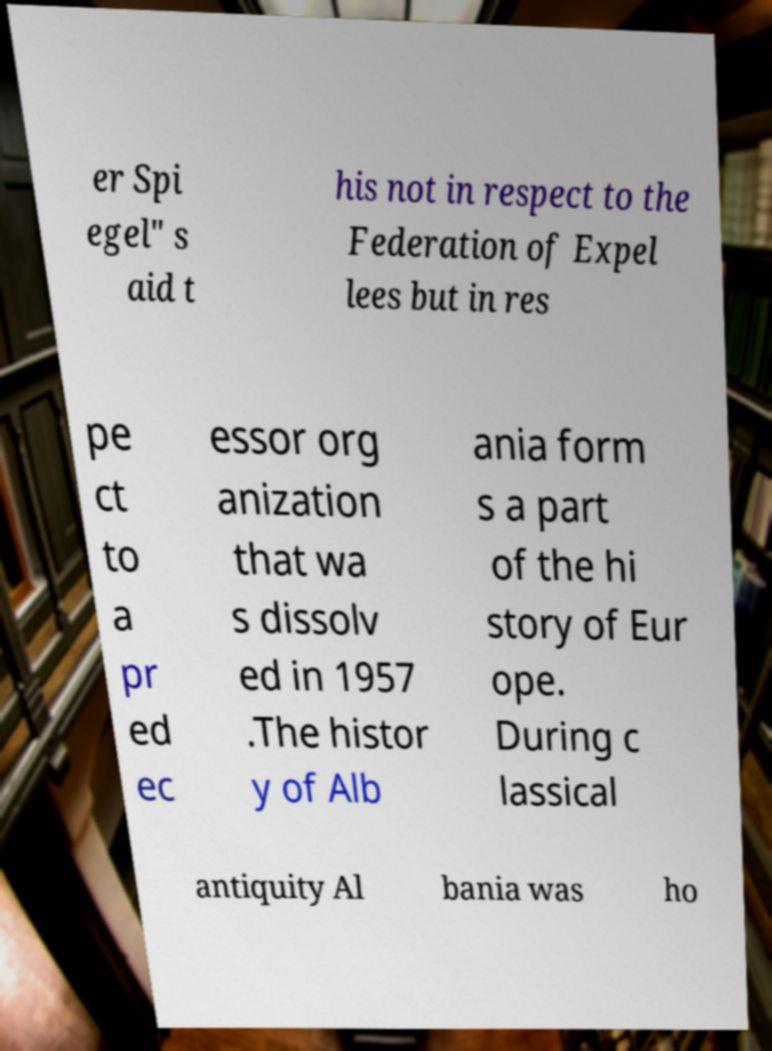Please identify and transcribe the text found in this image. er Spi egel" s aid t his not in respect to the Federation of Expel lees but in res pe ct to a pr ed ec essor org anization that wa s dissolv ed in 1957 .The histor y of Alb ania form s a part of the hi story of Eur ope. During c lassical antiquity Al bania was ho 